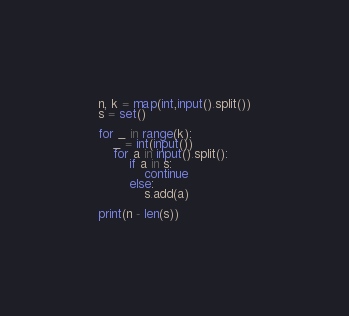<code> <loc_0><loc_0><loc_500><loc_500><_Python_>n, k = map(int,input().split())
s = set()

for _ in range(k):
    _ = int(input())
    for a in input().split():
        if a in s:
            continue
        else:
            s.add(a)

print(n - len(s))</code> 